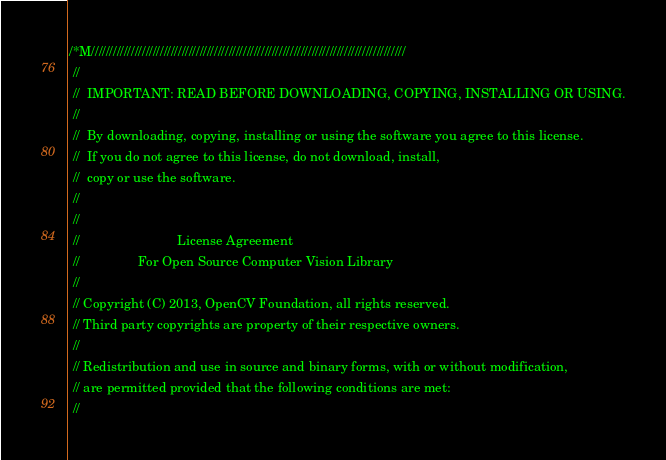Convert code to text. <code><loc_0><loc_0><loc_500><loc_500><_C++_>/*M///////////////////////////////////////////////////////////////////////////////////////
 //
 //  IMPORTANT: READ BEFORE DOWNLOADING, COPYING, INSTALLING OR USING.
 //
 //  By downloading, copying, installing or using the software you agree to this license.
 //  If you do not agree to this license, do not download, install,
 //  copy or use the software.
 //
 //
 //                           License Agreement
 //                For Open Source Computer Vision Library
 //
 // Copyright (C) 2013, OpenCV Foundation, all rights reserved.
 // Third party copyrights are property of their respective owners.
 //
 // Redistribution and use in source and binary forms, with or without modification,
 // are permitted provided that the following conditions are met:
 //</code> 